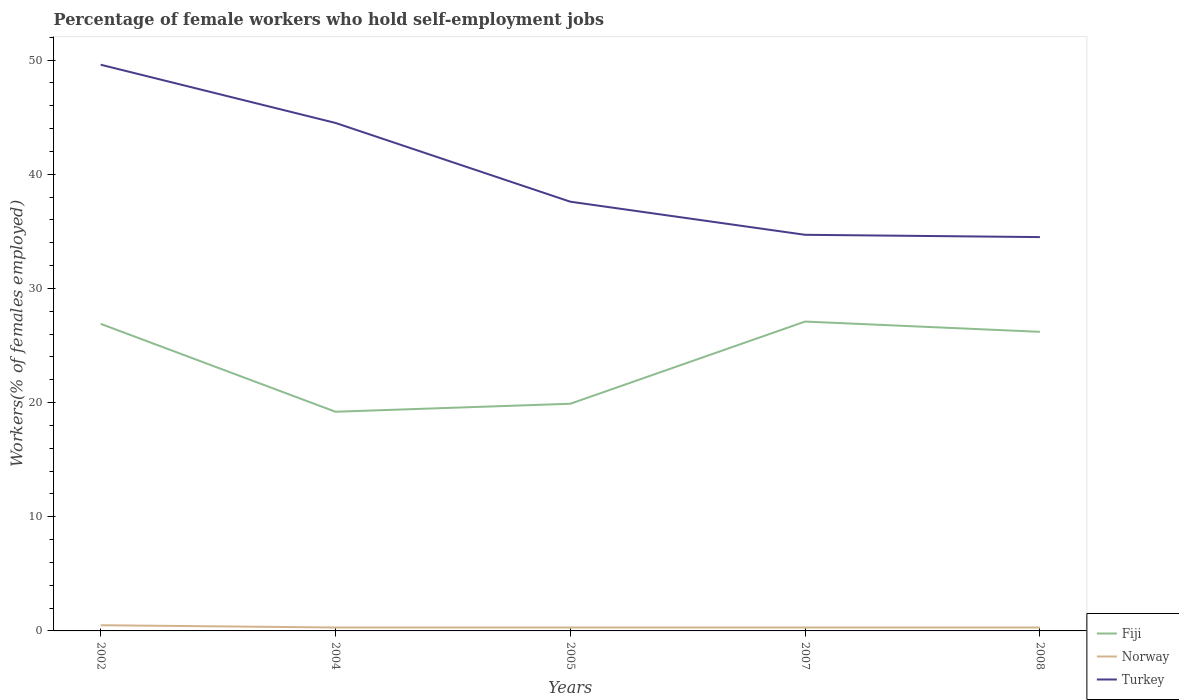Does the line corresponding to Fiji intersect with the line corresponding to Norway?
Offer a very short reply. No. Across all years, what is the maximum percentage of self-employed female workers in Turkey?
Make the answer very short. 34.5. In which year was the percentage of self-employed female workers in Norway maximum?
Ensure brevity in your answer.  2004. What is the total percentage of self-employed female workers in Turkey in the graph?
Give a very brief answer. 2.9. What is the difference between the highest and the second highest percentage of self-employed female workers in Turkey?
Make the answer very short. 15.1. What is the difference between the highest and the lowest percentage of self-employed female workers in Turkey?
Offer a terse response. 2. Is the percentage of self-employed female workers in Turkey strictly greater than the percentage of self-employed female workers in Norway over the years?
Provide a short and direct response. No. What is the difference between two consecutive major ticks on the Y-axis?
Offer a terse response. 10. Are the values on the major ticks of Y-axis written in scientific E-notation?
Your answer should be very brief. No. Does the graph contain any zero values?
Your answer should be very brief. No. How many legend labels are there?
Make the answer very short. 3. How are the legend labels stacked?
Give a very brief answer. Vertical. What is the title of the graph?
Make the answer very short. Percentage of female workers who hold self-employment jobs. What is the label or title of the X-axis?
Keep it short and to the point. Years. What is the label or title of the Y-axis?
Your answer should be very brief. Workers(% of females employed). What is the Workers(% of females employed) of Fiji in 2002?
Your answer should be compact. 26.9. What is the Workers(% of females employed) in Norway in 2002?
Give a very brief answer. 0.5. What is the Workers(% of females employed) in Turkey in 2002?
Make the answer very short. 49.6. What is the Workers(% of females employed) in Fiji in 2004?
Make the answer very short. 19.2. What is the Workers(% of females employed) of Norway in 2004?
Offer a terse response. 0.3. What is the Workers(% of females employed) in Turkey in 2004?
Keep it short and to the point. 44.5. What is the Workers(% of females employed) of Fiji in 2005?
Your answer should be compact. 19.9. What is the Workers(% of females employed) of Norway in 2005?
Your response must be concise. 0.3. What is the Workers(% of females employed) in Turkey in 2005?
Your answer should be compact. 37.6. What is the Workers(% of females employed) of Fiji in 2007?
Provide a short and direct response. 27.1. What is the Workers(% of females employed) in Norway in 2007?
Ensure brevity in your answer.  0.3. What is the Workers(% of females employed) in Turkey in 2007?
Ensure brevity in your answer.  34.7. What is the Workers(% of females employed) in Fiji in 2008?
Keep it short and to the point. 26.2. What is the Workers(% of females employed) of Norway in 2008?
Offer a terse response. 0.3. What is the Workers(% of females employed) of Turkey in 2008?
Provide a short and direct response. 34.5. Across all years, what is the maximum Workers(% of females employed) of Fiji?
Make the answer very short. 27.1. Across all years, what is the maximum Workers(% of females employed) in Turkey?
Your answer should be very brief. 49.6. Across all years, what is the minimum Workers(% of females employed) in Fiji?
Make the answer very short. 19.2. Across all years, what is the minimum Workers(% of females employed) in Norway?
Keep it short and to the point. 0.3. Across all years, what is the minimum Workers(% of females employed) of Turkey?
Keep it short and to the point. 34.5. What is the total Workers(% of females employed) in Fiji in the graph?
Ensure brevity in your answer.  119.3. What is the total Workers(% of females employed) in Norway in the graph?
Offer a terse response. 1.7. What is the total Workers(% of females employed) in Turkey in the graph?
Keep it short and to the point. 200.9. What is the difference between the Workers(% of females employed) in Fiji in 2002 and that in 2004?
Give a very brief answer. 7.7. What is the difference between the Workers(% of females employed) of Norway in 2002 and that in 2004?
Your response must be concise. 0.2. What is the difference between the Workers(% of females employed) in Turkey in 2002 and that in 2004?
Make the answer very short. 5.1. What is the difference between the Workers(% of females employed) in Fiji in 2002 and that in 2005?
Provide a short and direct response. 7. What is the difference between the Workers(% of females employed) in Fiji in 2002 and that in 2007?
Offer a very short reply. -0.2. What is the difference between the Workers(% of females employed) of Norway in 2002 and that in 2007?
Keep it short and to the point. 0.2. What is the difference between the Workers(% of females employed) in Turkey in 2002 and that in 2007?
Provide a short and direct response. 14.9. What is the difference between the Workers(% of females employed) in Turkey in 2002 and that in 2008?
Your answer should be very brief. 15.1. What is the difference between the Workers(% of females employed) of Turkey in 2004 and that in 2005?
Ensure brevity in your answer.  6.9. What is the difference between the Workers(% of females employed) in Fiji in 2004 and that in 2007?
Your answer should be very brief. -7.9. What is the difference between the Workers(% of females employed) of Norway in 2004 and that in 2007?
Keep it short and to the point. 0. What is the difference between the Workers(% of females employed) of Turkey in 2004 and that in 2007?
Provide a short and direct response. 9.8. What is the difference between the Workers(% of females employed) of Turkey in 2004 and that in 2008?
Provide a short and direct response. 10. What is the difference between the Workers(% of females employed) in Fiji in 2005 and that in 2007?
Ensure brevity in your answer.  -7.2. What is the difference between the Workers(% of females employed) in Norway in 2005 and that in 2007?
Provide a short and direct response. 0. What is the difference between the Workers(% of females employed) of Fiji in 2005 and that in 2008?
Offer a very short reply. -6.3. What is the difference between the Workers(% of females employed) in Turkey in 2005 and that in 2008?
Offer a terse response. 3.1. What is the difference between the Workers(% of females employed) of Fiji in 2002 and the Workers(% of females employed) of Norway in 2004?
Your response must be concise. 26.6. What is the difference between the Workers(% of females employed) of Fiji in 2002 and the Workers(% of females employed) of Turkey in 2004?
Offer a terse response. -17.6. What is the difference between the Workers(% of females employed) of Norway in 2002 and the Workers(% of females employed) of Turkey in 2004?
Your answer should be very brief. -44. What is the difference between the Workers(% of females employed) in Fiji in 2002 and the Workers(% of females employed) in Norway in 2005?
Provide a succinct answer. 26.6. What is the difference between the Workers(% of females employed) of Norway in 2002 and the Workers(% of females employed) of Turkey in 2005?
Your answer should be compact. -37.1. What is the difference between the Workers(% of females employed) of Fiji in 2002 and the Workers(% of females employed) of Norway in 2007?
Provide a succinct answer. 26.6. What is the difference between the Workers(% of females employed) in Norway in 2002 and the Workers(% of females employed) in Turkey in 2007?
Provide a succinct answer. -34.2. What is the difference between the Workers(% of females employed) in Fiji in 2002 and the Workers(% of females employed) in Norway in 2008?
Provide a succinct answer. 26.6. What is the difference between the Workers(% of females employed) in Fiji in 2002 and the Workers(% of females employed) in Turkey in 2008?
Provide a succinct answer. -7.6. What is the difference between the Workers(% of females employed) of Norway in 2002 and the Workers(% of females employed) of Turkey in 2008?
Provide a succinct answer. -34. What is the difference between the Workers(% of females employed) of Fiji in 2004 and the Workers(% of females employed) of Turkey in 2005?
Give a very brief answer. -18.4. What is the difference between the Workers(% of females employed) in Norway in 2004 and the Workers(% of females employed) in Turkey in 2005?
Make the answer very short. -37.3. What is the difference between the Workers(% of females employed) of Fiji in 2004 and the Workers(% of females employed) of Turkey in 2007?
Ensure brevity in your answer.  -15.5. What is the difference between the Workers(% of females employed) in Norway in 2004 and the Workers(% of females employed) in Turkey in 2007?
Your response must be concise. -34.4. What is the difference between the Workers(% of females employed) of Fiji in 2004 and the Workers(% of females employed) of Turkey in 2008?
Offer a very short reply. -15.3. What is the difference between the Workers(% of females employed) of Norway in 2004 and the Workers(% of females employed) of Turkey in 2008?
Your answer should be very brief. -34.2. What is the difference between the Workers(% of females employed) in Fiji in 2005 and the Workers(% of females employed) in Norway in 2007?
Keep it short and to the point. 19.6. What is the difference between the Workers(% of females employed) in Fiji in 2005 and the Workers(% of females employed) in Turkey in 2007?
Your answer should be compact. -14.8. What is the difference between the Workers(% of females employed) of Norway in 2005 and the Workers(% of females employed) of Turkey in 2007?
Your answer should be compact. -34.4. What is the difference between the Workers(% of females employed) in Fiji in 2005 and the Workers(% of females employed) in Norway in 2008?
Offer a very short reply. 19.6. What is the difference between the Workers(% of females employed) in Fiji in 2005 and the Workers(% of females employed) in Turkey in 2008?
Give a very brief answer. -14.6. What is the difference between the Workers(% of females employed) of Norway in 2005 and the Workers(% of females employed) of Turkey in 2008?
Keep it short and to the point. -34.2. What is the difference between the Workers(% of females employed) in Fiji in 2007 and the Workers(% of females employed) in Norway in 2008?
Provide a succinct answer. 26.8. What is the difference between the Workers(% of females employed) of Norway in 2007 and the Workers(% of females employed) of Turkey in 2008?
Give a very brief answer. -34.2. What is the average Workers(% of females employed) of Fiji per year?
Ensure brevity in your answer.  23.86. What is the average Workers(% of females employed) in Norway per year?
Offer a terse response. 0.34. What is the average Workers(% of females employed) of Turkey per year?
Your answer should be compact. 40.18. In the year 2002, what is the difference between the Workers(% of females employed) in Fiji and Workers(% of females employed) in Norway?
Give a very brief answer. 26.4. In the year 2002, what is the difference between the Workers(% of females employed) of Fiji and Workers(% of females employed) of Turkey?
Your answer should be very brief. -22.7. In the year 2002, what is the difference between the Workers(% of females employed) in Norway and Workers(% of females employed) in Turkey?
Give a very brief answer. -49.1. In the year 2004, what is the difference between the Workers(% of females employed) of Fiji and Workers(% of females employed) of Turkey?
Provide a succinct answer. -25.3. In the year 2004, what is the difference between the Workers(% of females employed) in Norway and Workers(% of females employed) in Turkey?
Ensure brevity in your answer.  -44.2. In the year 2005, what is the difference between the Workers(% of females employed) of Fiji and Workers(% of females employed) of Norway?
Ensure brevity in your answer.  19.6. In the year 2005, what is the difference between the Workers(% of females employed) of Fiji and Workers(% of females employed) of Turkey?
Your answer should be compact. -17.7. In the year 2005, what is the difference between the Workers(% of females employed) in Norway and Workers(% of females employed) in Turkey?
Give a very brief answer. -37.3. In the year 2007, what is the difference between the Workers(% of females employed) of Fiji and Workers(% of females employed) of Norway?
Your answer should be compact. 26.8. In the year 2007, what is the difference between the Workers(% of females employed) in Norway and Workers(% of females employed) in Turkey?
Provide a short and direct response. -34.4. In the year 2008, what is the difference between the Workers(% of females employed) in Fiji and Workers(% of females employed) in Norway?
Make the answer very short. 25.9. In the year 2008, what is the difference between the Workers(% of females employed) in Fiji and Workers(% of females employed) in Turkey?
Your answer should be very brief. -8.3. In the year 2008, what is the difference between the Workers(% of females employed) in Norway and Workers(% of females employed) in Turkey?
Make the answer very short. -34.2. What is the ratio of the Workers(% of females employed) of Fiji in 2002 to that in 2004?
Provide a succinct answer. 1.4. What is the ratio of the Workers(% of females employed) in Turkey in 2002 to that in 2004?
Offer a very short reply. 1.11. What is the ratio of the Workers(% of females employed) of Fiji in 2002 to that in 2005?
Offer a very short reply. 1.35. What is the ratio of the Workers(% of females employed) of Norway in 2002 to that in 2005?
Make the answer very short. 1.67. What is the ratio of the Workers(% of females employed) of Turkey in 2002 to that in 2005?
Your answer should be very brief. 1.32. What is the ratio of the Workers(% of females employed) of Norway in 2002 to that in 2007?
Keep it short and to the point. 1.67. What is the ratio of the Workers(% of females employed) of Turkey in 2002 to that in 2007?
Ensure brevity in your answer.  1.43. What is the ratio of the Workers(% of females employed) of Fiji in 2002 to that in 2008?
Your response must be concise. 1.03. What is the ratio of the Workers(% of females employed) of Norway in 2002 to that in 2008?
Keep it short and to the point. 1.67. What is the ratio of the Workers(% of females employed) in Turkey in 2002 to that in 2008?
Make the answer very short. 1.44. What is the ratio of the Workers(% of females employed) of Fiji in 2004 to that in 2005?
Keep it short and to the point. 0.96. What is the ratio of the Workers(% of females employed) in Turkey in 2004 to that in 2005?
Give a very brief answer. 1.18. What is the ratio of the Workers(% of females employed) in Fiji in 2004 to that in 2007?
Make the answer very short. 0.71. What is the ratio of the Workers(% of females employed) in Turkey in 2004 to that in 2007?
Make the answer very short. 1.28. What is the ratio of the Workers(% of females employed) in Fiji in 2004 to that in 2008?
Offer a terse response. 0.73. What is the ratio of the Workers(% of females employed) of Turkey in 2004 to that in 2008?
Make the answer very short. 1.29. What is the ratio of the Workers(% of females employed) of Fiji in 2005 to that in 2007?
Ensure brevity in your answer.  0.73. What is the ratio of the Workers(% of females employed) in Turkey in 2005 to that in 2007?
Provide a succinct answer. 1.08. What is the ratio of the Workers(% of females employed) in Fiji in 2005 to that in 2008?
Ensure brevity in your answer.  0.76. What is the ratio of the Workers(% of females employed) of Norway in 2005 to that in 2008?
Give a very brief answer. 1. What is the ratio of the Workers(% of females employed) of Turkey in 2005 to that in 2008?
Make the answer very short. 1.09. What is the ratio of the Workers(% of females employed) in Fiji in 2007 to that in 2008?
Offer a very short reply. 1.03. What is the ratio of the Workers(% of females employed) in Norway in 2007 to that in 2008?
Your answer should be compact. 1. What is the ratio of the Workers(% of females employed) in Turkey in 2007 to that in 2008?
Make the answer very short. 1.01. What is the difference between the highest and the second highest Workers(% of females employed) in Fiji?
Offer a very short reply. 0.2. 